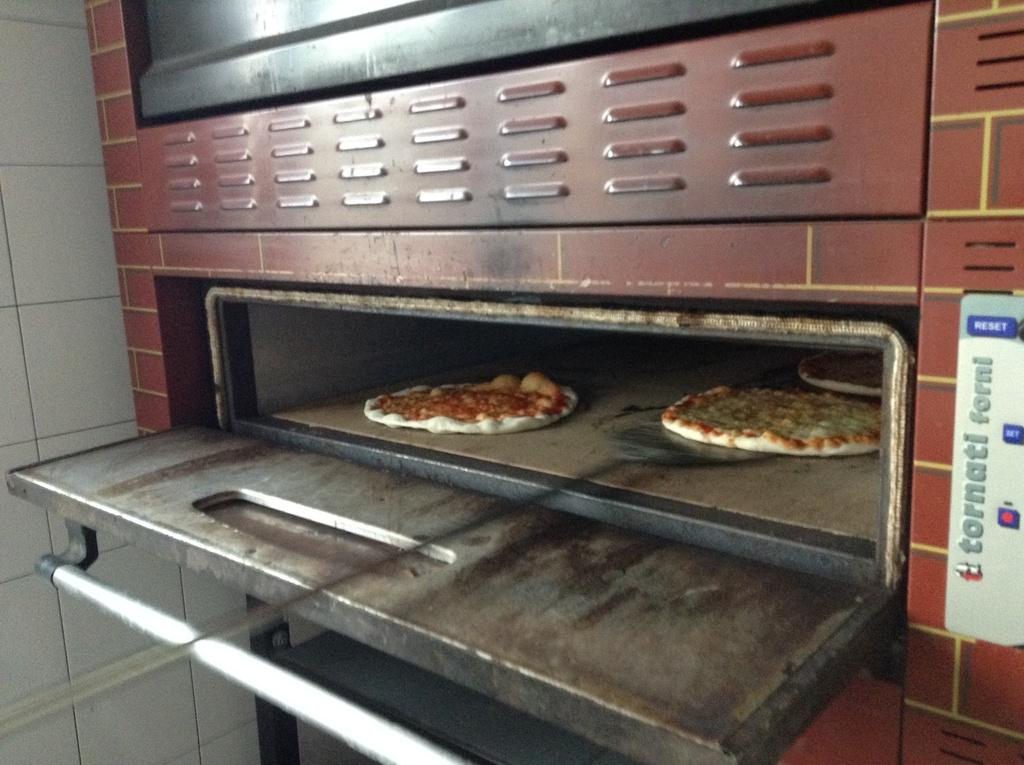<image>
Describe the image concisely. Three pizzas are in an industrial size tornati forni oven with the door open 